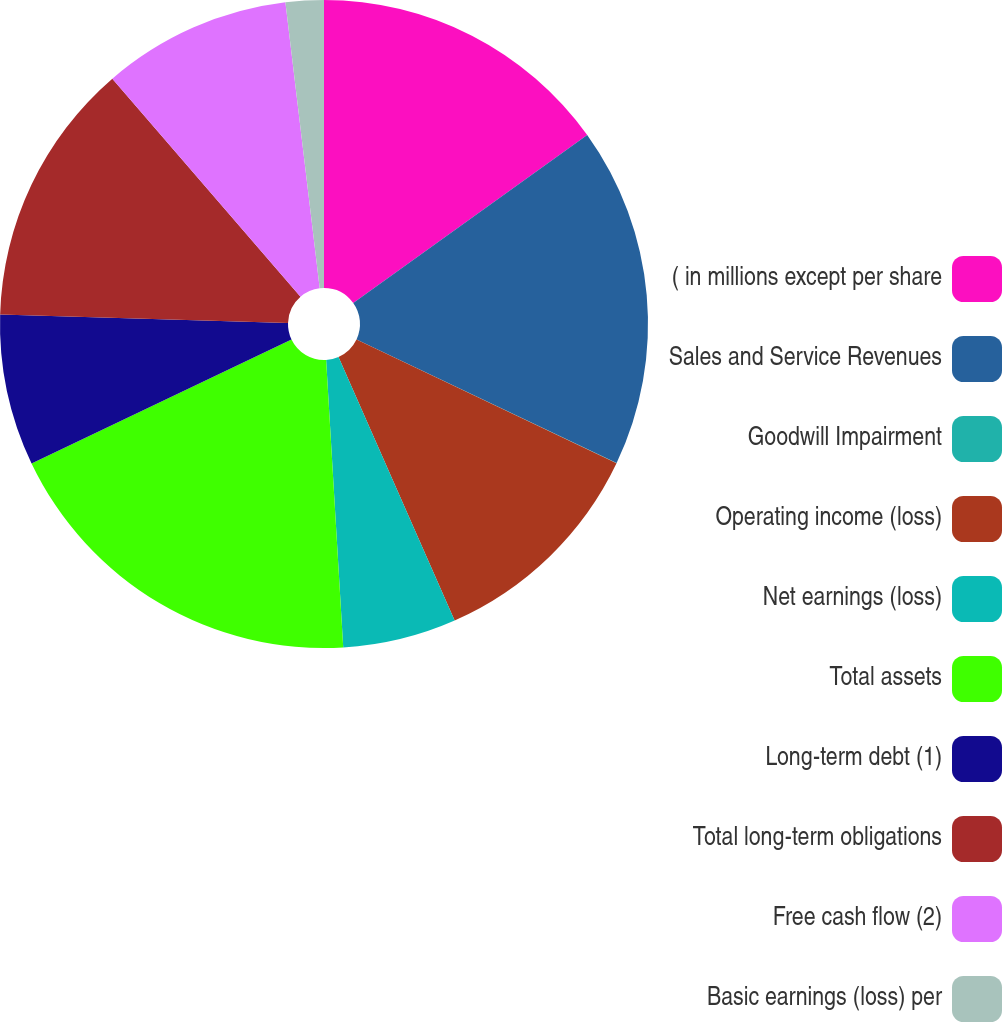<chart> <loc_0><loc_0><loc_500><loc_500><pie_chart><fcel>( in millions except per share<fcel>Sales and Service Revenues<fcel>Goodwill Impairment<fcel>Operating income (loss)<fcel>Net earnings (loss)<fcel>Total assets<fcel>Long-term debt (1)<fcel>Total long-term obligations<fcel>Free cash flow (2)<fcel>Basic earnings (loss) per<nl><fcel>15.09%<fcel>16.97%<fcel>0.01%<fcel>11.32%<fcel>5.66%<fcel>18.86%<fcel>7.55%<fcel>13.2%<fcel>9.43%<fcel>1.9%<nl></chart> 